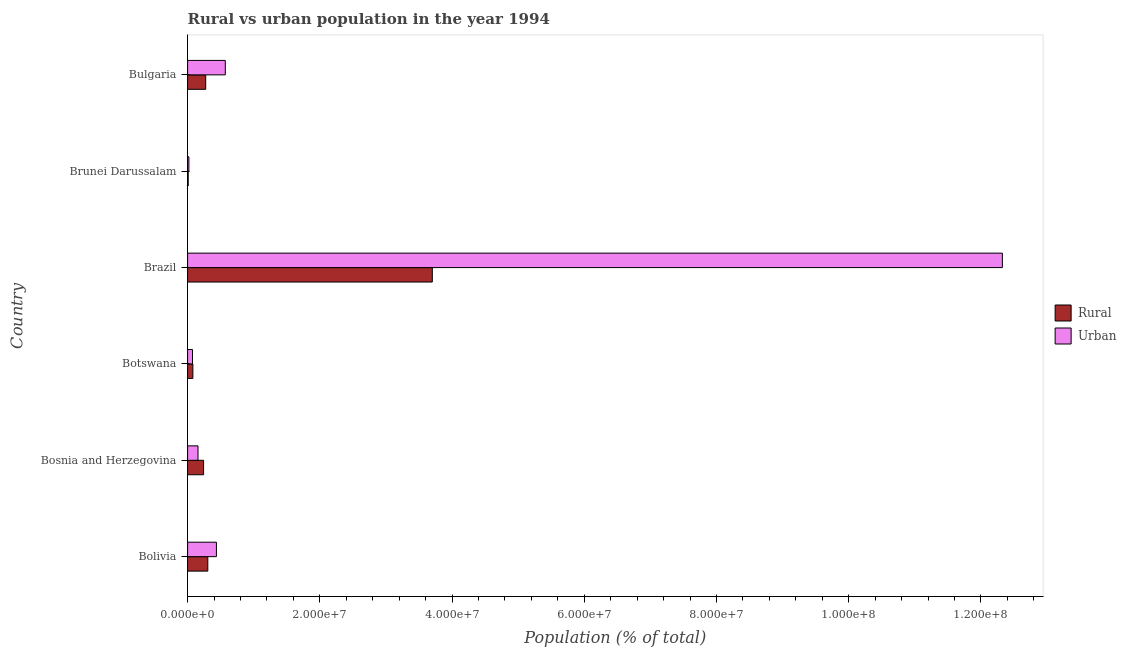Are the number of bars on each tick of the Y-axis equal?
Your response must be concise. Yes. How many bars are there on the 5th tick from the top?
Provide a short and direct response. 2. What is the label of the 4th group of bars from the top?
Your response must be concise. Botswana. What is the urban population density in Brunei Darussalam?
Provide a short and direct response. 1.96e+05. Across all countries, what is the maximum rural population density?
Offer a very short reply. 3.70e+07. Across all countries, what is the minimum urban population density?
Offer a very short reply. 1.96e+05. In which country was the rural population density minimum?
Your answer should be compact. Brunei Darussalam. What is the total urban population density in the graph?
Provide a short and direct response. 1.36e+08. What is the difference between the urban population density in Botswana and that in Brazil?
Make the answer very short. -1.23e+08. What is the difference between the urban population density in Brazil and the rural population density in Bosnia and Herzegovina?
Make the answer very short. 1.21e+08. What is the average urban population density per country?
Give a very brief answer. 2.26e+07. What is the difference between the urban population density and rural population density in Bolivia?
Give a very brief answer. 1.30e+06. What is the ratio of the urban population density in Brazil to that in Bulgaria?
Your answer should be compact. 21.61. Is the difference between the urban population density in Bosnia and Herzegovina and Bulgaria greater than the difference between the rural population density in Bosnia and Herzegovina and Bulgaria?
Provide a short and direct response. No. What is the difference between the highest and the second highest rural population density?
Ensure brevity in your answer.  3.40e+07. What is the difference between the highest and the lowest urban population density?
Give a very brief answer. 1.23e+08. In how many countries, is the rural population density greater than the average rural population density taken over all countries?
Offer a very short reply. 1. Is the sum of the urban population density in Bolivia and Brazil greater than the maximum rural population density across all countries?
Provide a short and direct response. Yes. What does the 1st bar from the top in Brazil represents?
Make the answer very short. Urban. What does the 1st bar from the bottom in Botswana represents?
Keep it short and to the point. Rural. How many bars are there?
Your answer should be very brief. 12. Are the values on the major ticks of X-axis written in scientific E-notation?
Your answer should be very brief. Yes. Does the graph contain any zero values?
Give a very brief answer. No. How many legend labels are there?
Provide a short and direct response. 2. How are the legend labels stacked?
Provide a succinct answer. Vertical. What is the title of the graph?
Keep it short and to the point. Rural vs urban population in the year 1994. What is the label or title of the X-axis?
Offer a very short reply. Population (% of total). What is the label or title of the Y-axis?
Keep it short and to the point. Country. What is the Population (% of total) in Rural in Bolivia?
Your answer should be very brief. 3.06e+06. What is the Population (% of total) in Urban in Bolivia?
Make the answer very short. 4.36e+06. What is the Population (% of total) in Rural in Bosnia and Herzegovina?
Provide a short and direct response. 2.42e+06. What is the Population (% of total) in Urban in Bosnia and Herzegovina?
Provide a succinct answer. 1.57e+06. What is the Population (% of total) in Rural in Botswana?
Make the answer very short. 7.98e+05. What is the Population (% of total) of Urban in Botswana?
Make the answer very short. 7.41e+05. What is the Population (% of total) in Rural in Brazil?
Your response must be concise. 3.70e+07. What is the Population (% of total) in Urban in Brazil?
Provide a short and direct response. 1.23e+08. What is the Population (% of total) of Rural in Brunei Darussalam?
Your answer should be compact. 9.16e+04. What is the Population (% of total) of Urban in Brunei Darussalam?
Provide a succinct answer. 1.96e+05. What is the Population (% of total) of Rural in Bulgaria?
Provide a short and direct response. 2.74e+06. What is the Population (% of total) of Urban in Bulgaria?
Your answer should be very brief. 5.70e+06. Across all countries, what is the maximum Population (% of total) of Rural?
Your response must be concise. 3.70e+07. Across all countries, what is the maximum Population (% of total) in Urban?
Make the answer very short. 1.23e+08. Across all countries, what is the minimum Population (% of total) in Rural?
Make the answer very short. 9.16e+04. Across all countries, what is the minimum Population (% of total) in Urban?
Offer a terse response. 1.96e+05. What is the total Population (% of total) of Rural in the graph?
Your response must be concise. 4.61e+07. What is the total Population (% of total) in Urban in the graph?
Provide a succinct answer. 1.36e+08. What is the difference between the Population (% of total) of Rural in Bolivia and that in Bosnia and Herzegovina?
Provide a short and direct response. 6.40e+05. What is the difference between the Population (% of total) of Urban in Bolivia and that in Bosnia and Herzegovina?
Offer a terse response. 2.79e+06. What is the difference between the Population (% of total) in Rural in Bolivia and that in Botswana?
Your answer should be compact. 2.26e+06. What is the difference between the Population (% of total) of Urban in Bolivia and that in Botswana?
Ensure brevity in your answer.  3.62e+06. What is the difference between the Population (% of total) of Rural in Bolivia and that in Brazil?
Your answer should be compact. -3.40e+07. What is the difference between the Population (% of total) in Urban in Bolivia and that in Brazil?
Provide a succinct answer. -1.19e+08. What is the difference between the Population (% of total) in Rural in Bolivia and that in Brunei Darussalam?
Your response must be concise. 2.97e+06. What is the difference between the Population (% of total) of Urban in Bolivia and that in Brunei Darussalam?
Give a very brief answer. 4.17e+06. What is the difference between the Population (% of total) of Rural in Bolivia and that in Bulgaria?
Make the answer very short. 3.18e+05. What is the difference between the Population (% of total) of Urban in Bolivia and that in Bulgaria?
Offer a very short reply. -1.34e+06. What is the difference between the Population (% of total) in Rural in Bosnia and Herzegovina and that in Botswana?
Your response must be concise. 1.62e+06. What is the difference between the Population (% of total) of Urban in Bosnia and Herzegovina and that in Botswana?
Make the answer very short. 8.33e+05. What is the difference between the Population (% of total) of Rural in Bosnia and Herzegovina and that in Brazil?
Make the answer very short. -3.46e+07. What is the difference between the Population (% of total) in Urban in Bosnia and Herzegovina and that in Brazil?
Your response must be concise. -1.22e+08. What is the difference between the Population (% of total) of Rural in Bosnia and Herzegovina and that in Brunei Darussalam?
Make the answer very short. 2.33e+06. What is the difference between the Population (% of total) of Urban in Bosnia and Herzegovina and that in Brunei Darussalam?
Give a very brief answer. 1.38e+06. What is the difference between the Population (% of total) in Rural in Bosnia and Herzegovina and that in Bulgaria?
Your response must be concise. -3.21e+05. What is the difference between the Population (% of total) in Urban in Bosnia and Herzegovina and that in Bulgaria?
Keep it short and to the point. -4.13e+06. What is the difference between the Population (% of total) of Rural in Botswana and that in Brazil?
Offer a terse response. -3.62e+07. What is the difference between the Population (% of total) in Urban in Botswana and that in Brazil?
Your response must be concise. -1.23e+08. What is the difference between the Population (% of total) of Rural in Botswana and that in Brunei Darussalam?
Your response must be concise. 7.07e+05. What is the difference between the Population (% of total) of Urban in Botswana and that in Brunei Darussalam?
Give a very brief answer. 5.45e+05. What is the difference between the Population (% of total) of Rural in Botswana and that in Bulgaria?
Keep it short and to the point. -1.94e+06. What is the difference between the Population (% of total) of Urban in Botswana and that in Bulgaria?
Make the answer very short. -4.96e+06. What is the difference between the Population (% of total) in Rural in Brazil and that in Brunei Darussalam?
Your response must be concise. 3.69e+07. What is the difference between the Population (% of total) of Urban in Brazil and that in Brunei Darussalam?
Make the answer very short. 1.23e+08. What is the difference between the Population (% of total) of Rural in Brazil and that in Bulgaria?
Your response must be concise. 3.43e+07. What is the difference between the Population (% of total) of Urban in Brazil and that in Bulgaria?
Give a very brief answer. 1.18e+08. What is the difference between the Population (% of total) of Rural in Brunei Darussalam and that in Bulgaria?
Make the answer very short. -2.65e+06. What is the difference between the Population (% of total) in Urban in Brunei Darussalam and that in Bulgaria?
Keep it short and to the point. -5.51e+06. What is the difference between the Population (% of total) in Rural in Bolivia and the Population (% of total) in Urban in Bosnia and Herzegovina?
Offer a very short reply. 1.48e+06. What is the difference between the Population (% of total) of Rural in Bolivia and the Population (% of total) of Urban in Botswana?
Give a very brief answer. 2.32e+06. What is the difference between the Population (% of total) in Rural in Bolivia and the Population (% of total) in Urban in Brazil?
Provide a short and direct response. -1.20e+08. What is the difference between the Population (% of total) of Rural in Bolivia and the Population (% of total) of Urban in Brunei Darussalam?
Offer a very short reply. 2.86e+06. What is the difference between the Population (% of total) of Rural in Bolivia and the Population (% of total) of Urban in Bulgaria?
Offer a terse response. -2.65e+06. What is the difference between the Population (% of total) in Rural in Bosnia and Herzegovina and the Population (% of total) in Urban in Botswana?
Ensure brevity in your answer.  1.68e+06. What is the difference between the Population (% of total) in Rural in Bosnia and Herzegovina and the Population (% of total) in Urban in Brazil?
Give a very brief answer. -1.21e+08. What is the difference between the Population (% of total) in Rural in Bosnia and Herzegovina and the Population (% of total) in Urban in Brunei Darussalam?
Offer a very short reply. 2.22e+06. What is the difference between the Population (% of total) in Rural in Bosnia and Herzegovina and the Population (% of total) in Urban in Bulgaria?
Provide a succinct answer. -3.29e+06. What is the difference between the Population (% of total) of Rural in Botswana and the Population (% of total) of Urban in Brazil?
Provide a short and direct response. -1.22e+08. What is the difference between the Population (% of total) in Rural in Botswana and the Population (% of total) in Urban in Brunei Darussalam?
Provide a succinct answer. 6.02e+05. What is the difference between the Population (% of total) of Rural in Botswana and the Population (% of total) of Urban in Bulgaria?
Your answer should be very brief. -4.91e+06. What is the difference between the Population (% of total) of Rural in Brazil and the Population (% of total) of Urban in Brunei Darussalam?
Keep it short and to the point. 3.68e+07. What is the difference between the Population (% of total) of Rural in Brazil and the Population (% of total) of Urban in Bulgaria?
Make the answer very short. 3.13e+07. What is the difference between the Population (% of total) in Rural in Brunei Darussalam and the Population (% of total) in Urban in Bulgaria?
Offer a terse response. -5.61e+06. What is the average Population (% of total) in Rural per country?
Provide a succinct answer. 7.69e+06. What is the average Population (% of total) in Urban per country?
Your answer should be very brief. 2.26e+07. What is the difference between the Population (% of total) of Rural and Population (% of total) of Urban in Bolivia?
Your answer should be compact. -1.30e+06. What is the difference between the Population (% of total) of Rural and Population (% of total) of Urban in Bosnia and Herzegovina?
Give a very brief answer. 8.44e+05. What is the difference between the Population (% of total) of Rural and Population (% of total) of Urban in Botswana?
Keep it short and to the point. 5.75e+04. What is the difference between the Population (% of total) in Rural and Population (% of total) in Urban in Brazil?
Your answer should be compact. -8.62e+07. What is the difference between the Population (% of total) in Rural and Population (% of total) in Urban in Brunei Darussalam?
Give a very brief answer. -1.04e+05. What is the difference between the Population (% of total) in Rural and Population (% of total) in Urban in Bulgaria?
Your answer should be very brief. -2.96e+06. What is the ratio of the Population (% of total) of Rural in Bolivia to that in Bosnia and Herzegovina?
Offer a very short reply. 1.26. What is the ratio of the Population (% of total) in Urban in Bolivia to that in Bosnia and Herzegovina?
Provide a succinct answer. 2.77. What is the ratio of the Population (% of total) in Rural in Bolivia to that in Botswana?
Provide a short and direct response. 3.83. What is the ratio of the Population (% of total) in Urban in Bolivia to that in Botswana?
Your response must be concise. 5.89. What is the ratio of the Population (% of total) in Rural in Bolivia to that in Brazil?
Make the answer very short. 0.08. What is the ratio of the Population (% of total) in Urban in Bolivia to that in Brazil?
Provide a short and direct response. 0.04. What is the ratio of the Population (% of total) in Rural in Bolivia to that in Brunei Darussalam?
Provide a succinct answer. 33.38. What is the ratio of the Population (% of total) of Urban in Bolivia to that in Brunei Darussalam?
Your response must be concise. 22.27. What is the ratio of the Population (% of total) of Rural in Bolivia to that in Bulgaria?
Offer a terse response. 1.12. What is the ratio of the Population (% of total) in Urban in Bolivia to that in Bulgaria?
Your response must be concise. 0.76. What is the ratio of the Population (% of total) of Rural in Bosnia and Herzegovina to that in Botswana?
Your answer should be compact. 3.03. What is the ratio of the Population (% of total) in Urban in Bosnia and Herzegovina to that in Botswana?
Ensure brevity in your answer.  2.12. What is the ratio of the Population (% of total) in Rural in Bosnia and Herzegovina to that in Brazil?
Provide a short and direct response. 0.07. What is the ratio of the Population (% of total) of Urban in Bosnia and Herzegovina to that in Brazil?
Your answer should be compact. 0.01. What is the ratio of the Population (% of total) of Rural in Bosnia and Herzegovina to that in Brunei Darussalam?
Ensure brevity in your answer.  26.39. What is the ratio of the Population (% of total) of Urban in Bosnia and Herzegovina to that in Brunei Darussalam?
Your response must be concise. 8.04. What is the ratio of the Population (% of total) of Rural in Bosnia and Herzegovina to that in Bulgaria?
Your response must be concise. 0.88. What is the ratio of the Population (% of total) in Urban in Bosnia and Herzegovina to that in Bulgaria?
Make the answer very short. 0.28. What is the ratio of the Population (% of total) of Rural in Botswana to that in Brazil?
Offer a very short reply. 0.02. What is the ratio of the Population (% of total) in Urban in Botswana to that in Brazil?
Provide a succinct answer. 0.01. What is the ratio of the Population (% of total) of Rural in Botswana to that in Brunei Darussalam?
Provide a succinct answer. 8.71. What is the ratio of the Population (% of total) of Urban in Botswana to that in Brunei Darussalam?
Offer a terse response. 3.78. What is the ratio of the Population (% of total) of Rural in Botswana to that in Bulgaria?
Your answer should be compact. 0.29. What is the ratio of the Population (% of total) of Urban in Botswana to that in Bulgaria?
Offer a very short reply. 0.13. What is the ratio of the Population (% of total) in Rural in Brazil to that in Brunei Darussalam?
Provide a succinct answer. 404.04. What is the ratio of the Population (% of total) in Urban in Brazil to that in Brunei Darussalam?
Provide a succinct answer. 629.41. What is the ratio of the Population (% of total) of Rural in Brazil to that in Bulgaria?
Give a very brief answer. 13.51. What is the ratio of the Population (% of total) in Urban in Brazil to that in Bulgaria?
Your answer should be compact. 21.61. What is the ratio of the Population (% of total) of Rural in Brunei Darussalam to that in Bulgaria?
Provide a succinct answer. 0.03. What is the ratio of the Population (% of total) of Urban in Brunei Darussalam to that in Bulgaria?
Provide a short and direct response. 0.03. What is the difference between the highest and the second highest Population (% of total) in Rural?
Your response must be concise. 3.40e+07. What is the difference between the highest and the second highest Population (% of total) of Urban?
Your answer should be very brief. 1.18e+08. What is the difference between the highest and the lowest Population (% of total) in Rural?
Your answer should be compact. 3.69e+07. What is the difference between the highest and the lowest Population (% of total) of Urban?
Your response must be concise. 1.23e+08. 